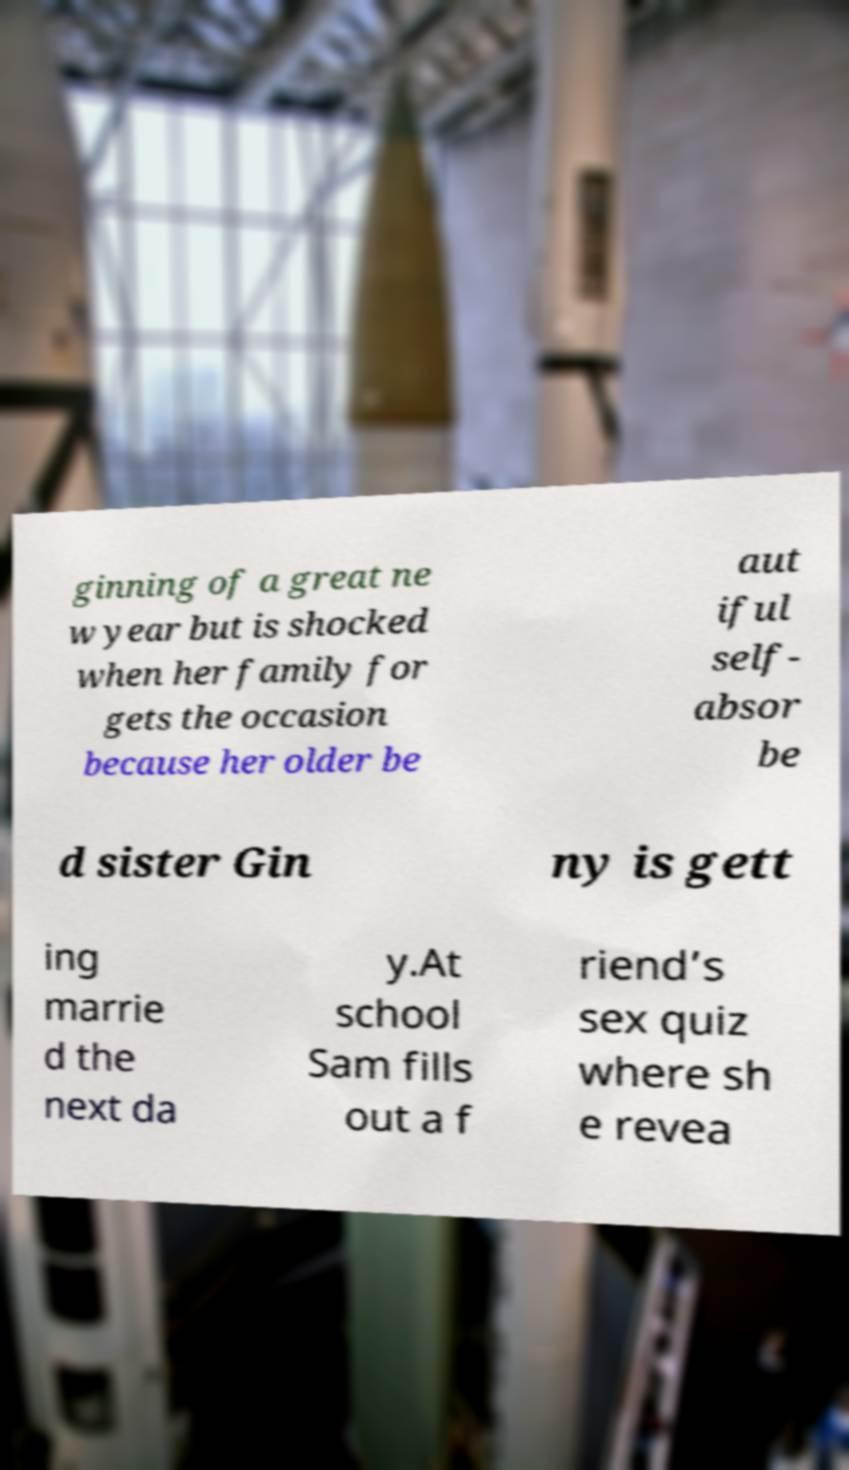Please read and relay the text visible in this image. What does it say? ginning of a great ne w year but is shocked when her family for gets the occasion because her older be aut iful self- absor be d sister Gin ny is gett ing marrie d the next da y.At school Sam fills out a f riend’s sex quiz where sh e revea 